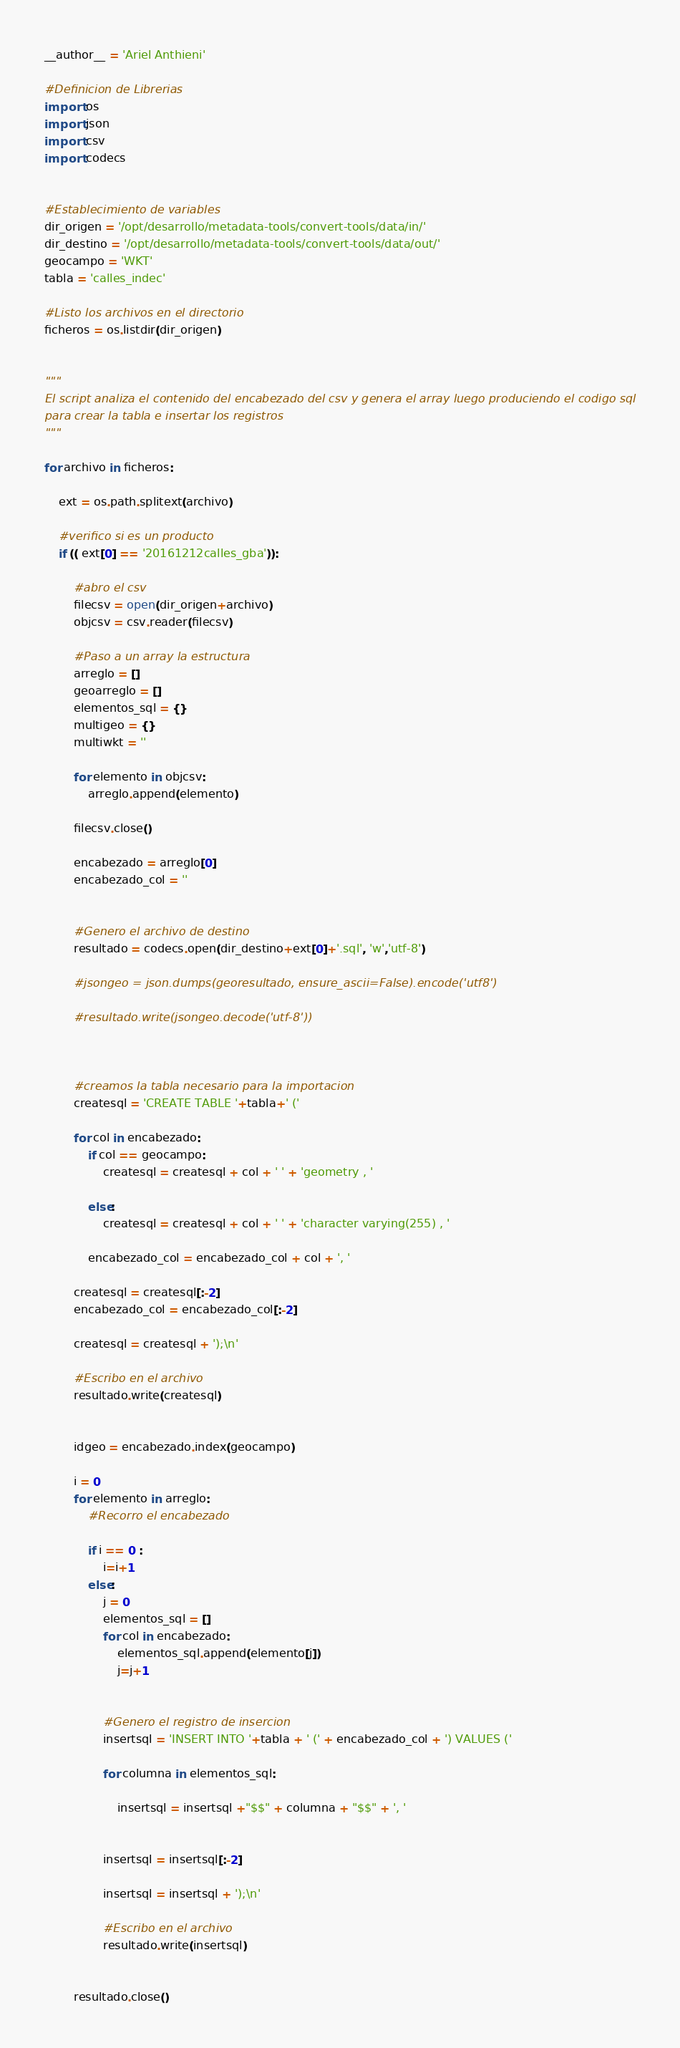Convert code to text. <code><loc_0><loc_0><loc_500><loc_500><_Python_>__author__ = 'Ariel Anthieni'

#Definicion de Librerias
import os
import json
import csv
import codecs


#Establecimiento de variables
dir_origen = '/opt/desarrollo/metadata-tools/convert-tools/data/in/'
dir_destino = '/opt/desarrollo/metadata-tools/convert-tools/data/out/'
geocampo = 'WKT'
tabla = 'calles_indec'

#Listo los archivos en el directorio
ficheros = os.listdir(dir_origen)


"""
El script analiza el contenido del encabezado del csv y genera el array luego produciendo el codigo sql
para crear la tabla e insertar los registros
"""

for archivo in ficheros:

    ext = os.path.splitext(archivo)

    #verifico si es un producto
    if (( ext[0] == '20161212calles_gba')):

        #abro el csv
        filecsv = open(dir_origen+archivo)
        objcsv = csv.reader(filecsv)

        #Paso a un array la estructura
        arreglo = []
        geoarreglo = []
        elementos_sql = {}
        multigeo = {}
        multiwkt = ''

        for elemento in objcsv:
            arreglo.append(elemento)

        filecsv.close()

        encabezado = arreglo[0]
        encabezado_col = ''


        #Genero el archivo de destino
        resultado = codecs.open(dir_destino+ext[0]+'.sql', 'w','utf-8')

        #jsongeo = json.dumps(georesultado, ensure_ascii=False).encode('utf8')

        #resultado.write(jsongeo.decode('utf-8'))



        #creamos la tabla necesario para la importacion
        createsql = 'CREATE TABLE '+tabla+' ('

        for col in encabezado:
            if col == geocampo:
                createsql = createsql + col + ' ' + 'geometry , '

            else:
                createsql = createsql + col + ' ' + 'character varying(255) , '

            encabezado_col = encabezado_col + col + ', '

        createsql = createsql[:-2]
        encabezado_col = encabezado_col[:-2]

        createsql = createsql + ');\n'

        #Escribo en el archivo
        resultado.write(createsql)


        idgeo = encabezado.index(geocampo)

        i = 0
        for elemento in arreglo:
            #Recorro el encabezado

            if i == 0 :
                i=i+1
            else:
                j = 0
                elementos_sql = []
                for col in encabezado:
                    elementos_sql.append(elemento[j])
                    j=j+1


                #Genero el registro de insercion
                insertsql = 'INSERT INTO '+tabla + ' (' + encabezado_col + ') VALUES ('

                for columna in elementos_sql:

                    insertsql = insertsql +"$$" + columna + "$$" + ', '


                insertsql = insertsql[:-2]

                insertsql = insertsql + ');\n'

                #Escribo en el archivo
                resultado.write(insertsql)


        resultado.close()


</code> 